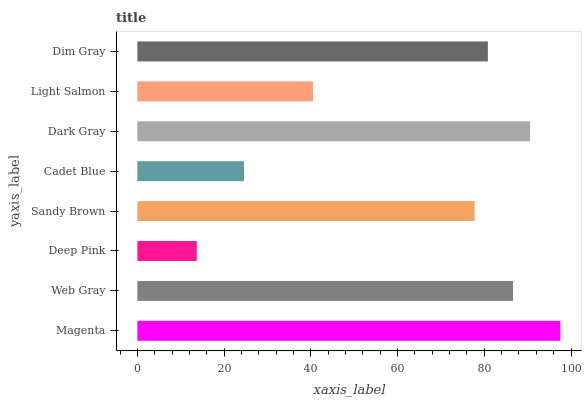Is Deep Pink the minimum?
Answer yes or no. Yes. Is Magenta the maximum?
Answer yes or no. Yes. Is Web Gray the minimum?
Answer yes or no. No. Is Web Gray the maximum?
Answer yes or no. No. Is Magenta greater than Web Gray?
Answer yes or no. Yes. Is Web Gray less than Magenta?
Answer yes or no. Yes. Is Web Gray greater than Magenta?
Answer yes or no. No. Is Magenta less than Web Gray?
Answer yes or no. No. Is Dim Gray the high median?
Answer yes or no. Yes. Is Sandy Brown the low median?
Answer yes or no. Yes. Is Light Salmon the high median?
Answer yes or no. No. Is Magenta the low median?
Answer yes or no. No. 